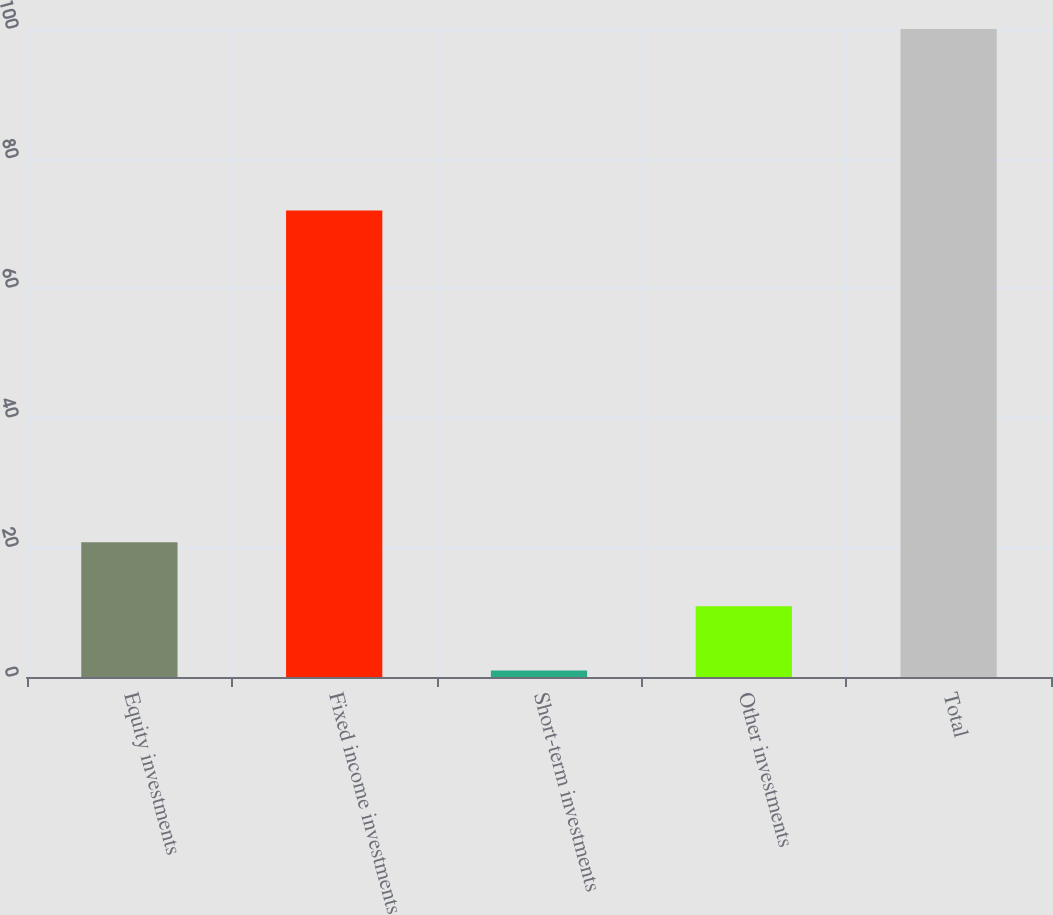Convert chart. <chart><loc_0><loc_0><loc_500><loc_500><bar_chart><fcel>Equity investments<fcel>Fixed income investments<fcel>Short-term investments<fcel>Other investments<fcel>Total<nl><fcel>20.8<fcel>72<fcel>1<fcel>10.9<fcel>100<nl></chart> 